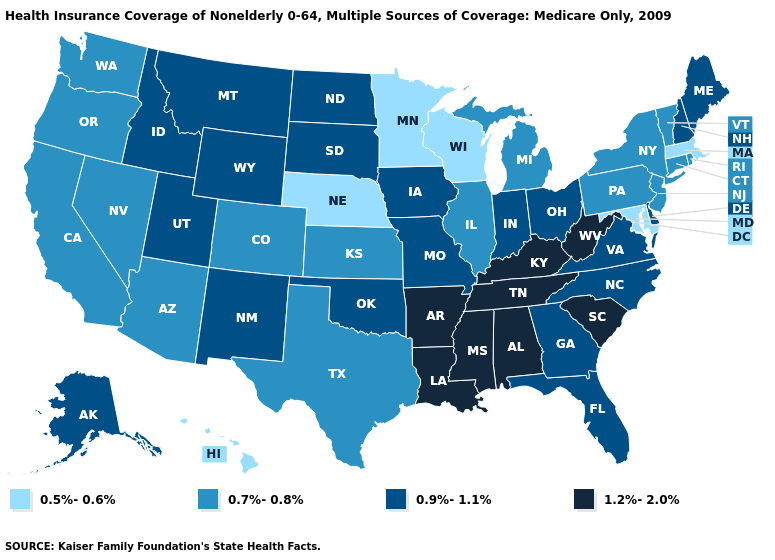Does Massachusetts have a higher value than Idaho?
Keep it brief. No. What is the highest value in the USA?
Quick response, please. 1.2%-2.0%. Name the states that have a value in the range 0.9%-1.1%?
Answer briefly. Alaska, Delaware, Florida, Georgia, Idaho, Indiana, Iowa, Maine, Missouri, Montana, New Hampshire, New Mexico, North Carolina, North Dakota, Ohio, Oklahoma, South Dakota, Utah, Virginia, Wyoming. Name the states that have a value in the range 1.2%-2.0%?
Short answer required. Alabama, Arkansas, Kentucky, Louisiana, Mississippi, South Carolina, Tennessee, West Virginia. Which states have the lowest value in the South?
Give a very brief answer. Maryland. Among the states that border New York , does Massachusetts have the lowest value?
Answer briefly. Yes. What is the value of Pennsylvania?
Quick response, please. 0.7%-0.8%. Among the states that border Virginia , does Kentucky have the lowest value?
Write a very short answer. No. Name the states that have a value in the range 1.2%-2.0%?
Write a very short answer. Alabama, Arkansas, Kentucky, Louisiana, Mississippi, South Carolina, Tennessee, West Virginia. What is the value of Nebraska?
Concise answer only. 0.5%-0.6%. Which states hav the highest value in the Northeast?
Quick response, please. Maine, New Hampshire. What is the value of Indiana?
Give a very brief answer. 0.9%-1.1%. What is the highest value in the MidWest ?
Concise answer only. 0.9%-1.1%. Name the states that have a value in the range 0.7%-0.8%?
Be succinct. Arizona, California, Colorado, Connecticut, Illinois, Kansas, Michigan, Nevada, New Jersey, New York, Oregon, Pennsylvania, Rhode Island, Texas, Vermont, Washington. Name the states that have a value in the range 0.9%-1.1%?
Give a very brief answer. Alaska, Delaware, Florida, Georgia, Idaho, Indiana, Iowa, Maine, Missouri, Montana, New Hampshire, New Mexico, North Carolina, North Dakota, Ohio, Oklahoma, South Dakota, Utah, Virginia, Wyoming. 